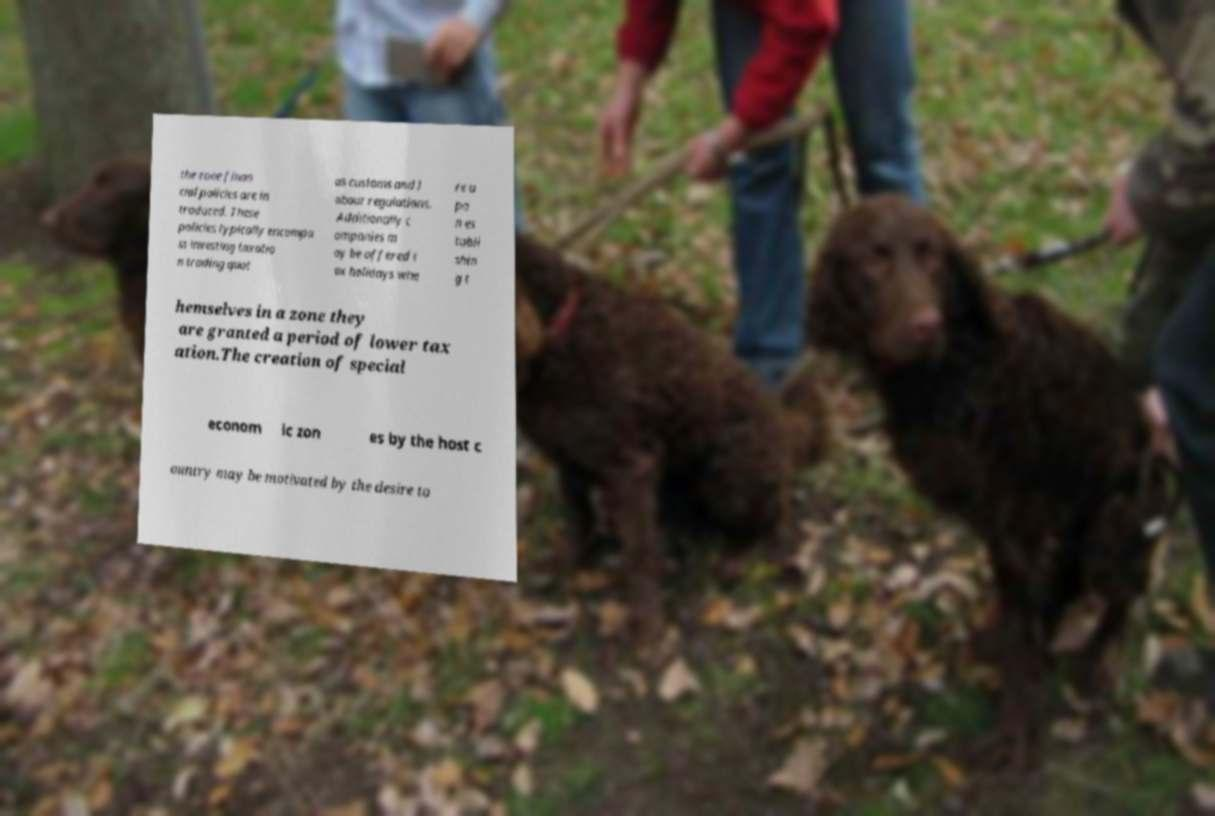Can you accurately transcribe the text from the provided image for me? the zone finan cial policies are in troduced. These policies typically encompa ss investing taxatio n trading quot as customs and l abour regulations. Additionally c ompanies m ay be offered t ax holidays whe re u po n es tabli shin g t hemselves in a zone they are granted a period of lower tax ation.The creation of special econom ic zon es by the host c ountry may be motivated by the desire to 